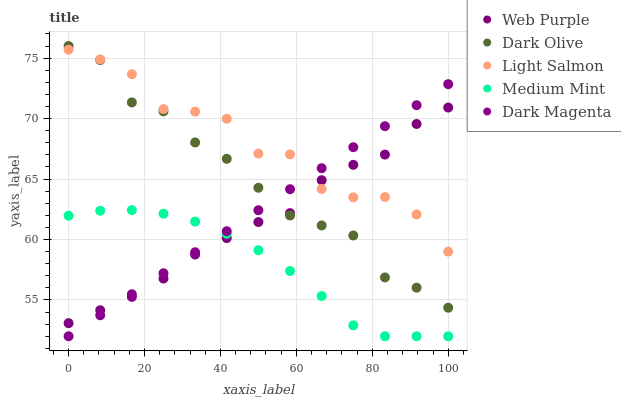Does Medium Mint have the minimum area under the curve?
Answer yes or no. Yes. Does Light Salmon have the maximum area under the curve?
Answer yes or no. Yes. Does Web Purple have the minimum area under the curve?
Answer yes or no. No. Does Web Purple have the maximum area under the curve?
Answer yes or no. No. Is Dark Magenta the smoothest?
Answer yes or no. Yes. Is Light Salmon the roughest?
Answer yes or no. Yes. Is Web Purple the smoothest?
Answer yes or no. No. Is Web Purple the roughest?
Answer yes or no. No. Does Medium Mint have the lowest value?
Answer yes or no. Yes. Does Web Purple have the lowest value?
Answer yes or no. No. Does Dark Olive have the highest value?
Answer yes or no. Yes. Does Web Purple have the highest value?
Answer yes or no. No. Is Medium Mint less than Light Salmon?
Answer yes or no. Yes. Is Dark Olive greater than Medium Mint?
Answer yes or no. Yes. Does Dark Olive intersect Light Salmon?
Answer yes or no. Yes. Is Dark Olive less than Light Salmon?
Answer yes or no. No. Is Dark Olive greater than Light Salmon?
Answer yes or no. No. Does Medium Mint intersect Light Salmon?
Answer yes or no. No. 